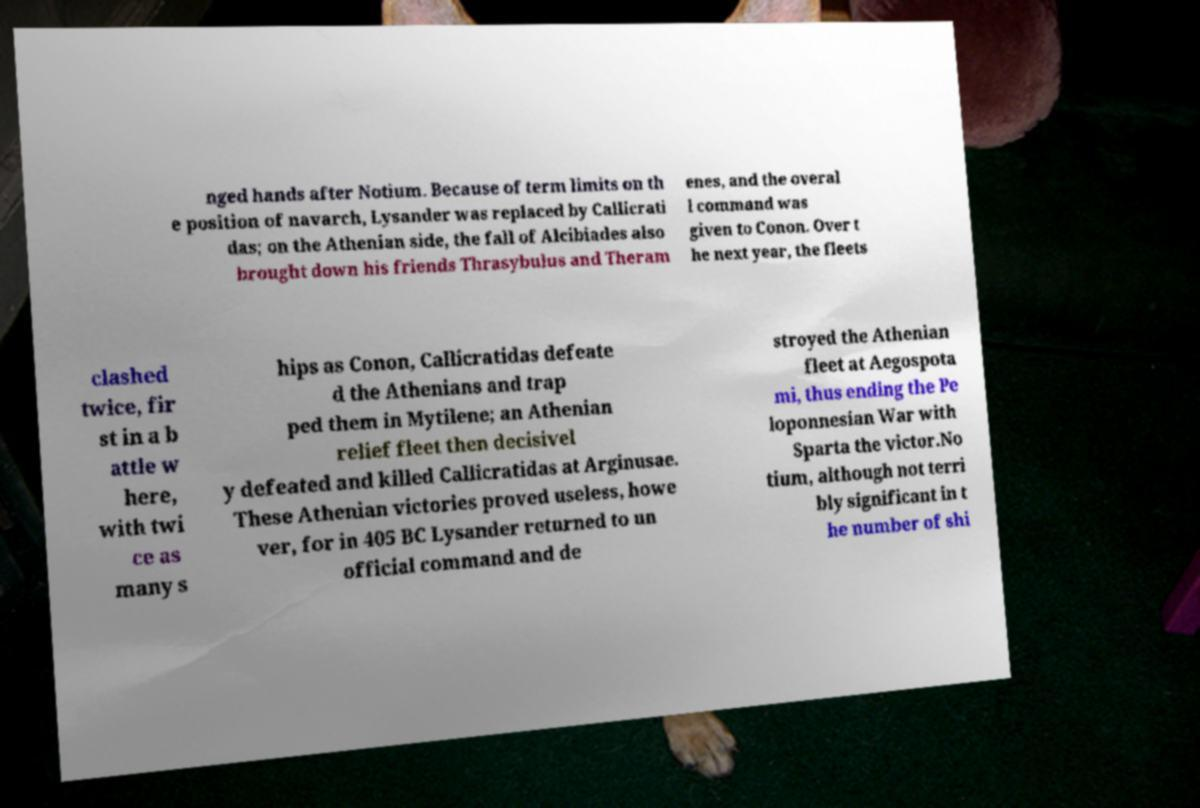Please identify and transcribe the text found in this image. nged hands after Notium. Because of term limits on th e position of navarch, Lysander was replaced by Callicrati das; on the Athenian side, the fall of Alcibiades also brought down his friends Thrasybulus and Theram enes, and the overal l command was given to Conon. Over t he next year, the fleets clashed twice, fir st in a b attle w here, with twi ce as many s hips as Conon, Callicratidas defeate d the Athenians and trap ped them in Mytilene; an Athenian relief fleet then decisivel y defeated and killed Callicratidas at Arginusae. These Athenian victories proved useless, howe ver, for in 405 BC Lysander returned to un official command and de stroyed the Athenian fleet at Aegospota mi, thus ending the Pe loponnesian War with Sparta the victor.No tium, although not terri bly significant in t he number of shi 